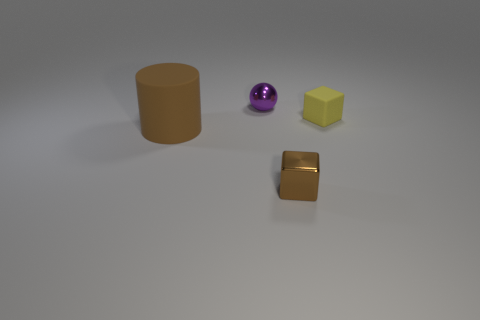Add 1 brown rubber things. How many objects exist? 5 Subtract all brown blocks. How many blocks are left? 1 Subtract all spheres. How many objects are left? 3 Subtract 1 blocks. How many blocks are left? 1 Subtract all purple balls. How many yellow blocks are left? 1 Subtract 0 cyan balls. How many objects are left? 4 Subtract all cyan spheres. Subtract all brown cubes. How many spheres are left? 1 Subtract all tiny yellow things. Subtract all matte things. How many objects are left? 1 Add 4 small yellow things. How many small yellow things are left? 5 Add 4 big red rubber cubes. How many big red rubber cubes exist? 4 